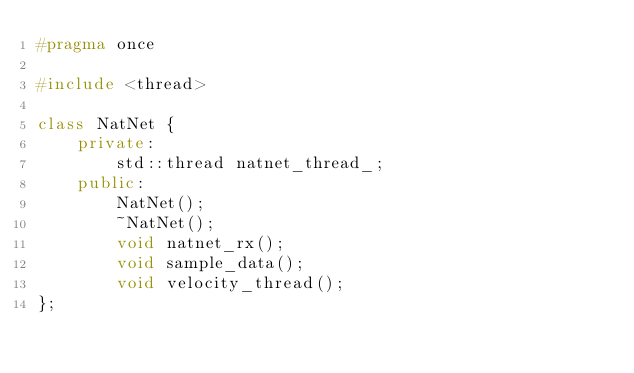Convert code to text. <code><loc_0><loc_0><loc_500><loc_500><_C++_>#pragma once

#include <thread>

class NatNet {
    private:
        std::thread natnet_thread_;      
    public:    
        NatNet();
        ~NatNet();
        void natnet_rx();
        void sample_data();
        void velocity_thread();
};</code> 